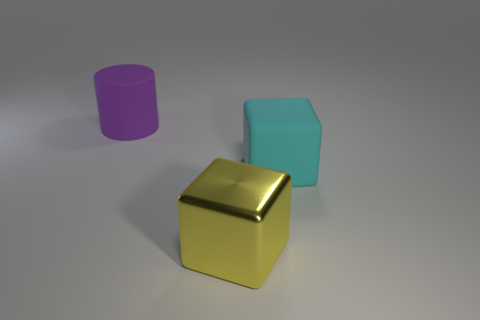How would you describe the texture of the objects' surfaces? The surfaces of the objects shown—namely the purple cylinder, the blue cube, and the gold cube—are smooth and reflective, suggesting a polished, possibly metallic texture. 